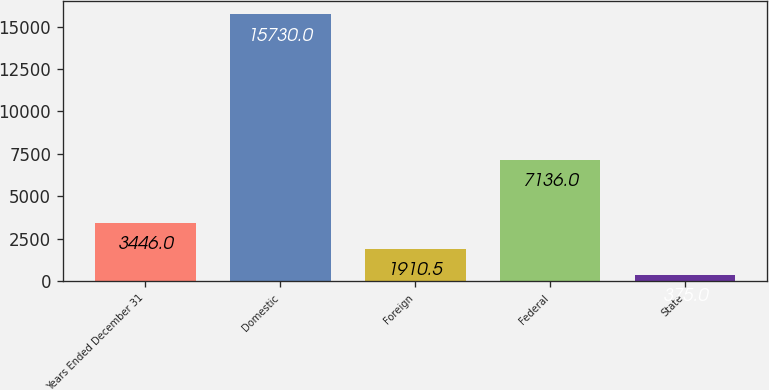<chart> <loc_0><loc_0><loc_500><loc_500><bar_chart><fcel>Years Ended December 31<fcel>Domestic<fcel>Foreign<fcel>Federal<fcel>State<nl><fcel>3446<fcel>15730<fcel>1910.5<fcel>7136<fcel>375<nl></chart> 